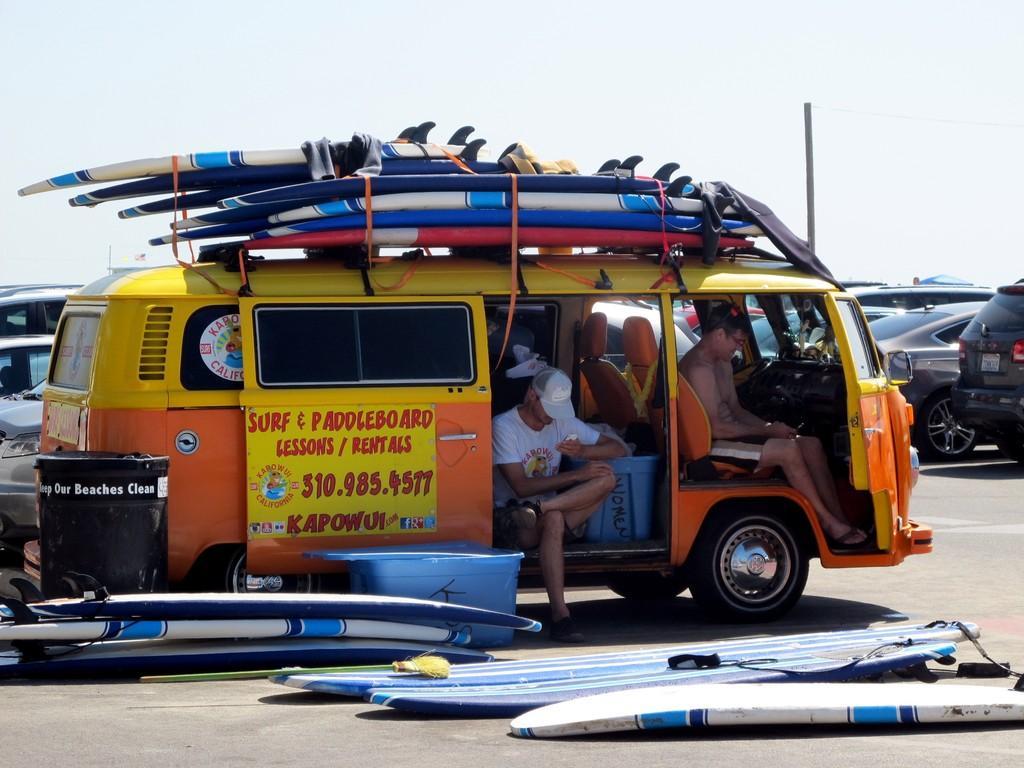Could you give a brief overview of what you see in this image? Persons are sitting inside this vehicle. In-front of this vehicle there is a container and surfboards. This is a black bin. Far there are number of vehicles. This is holding mobile and wore cap. 